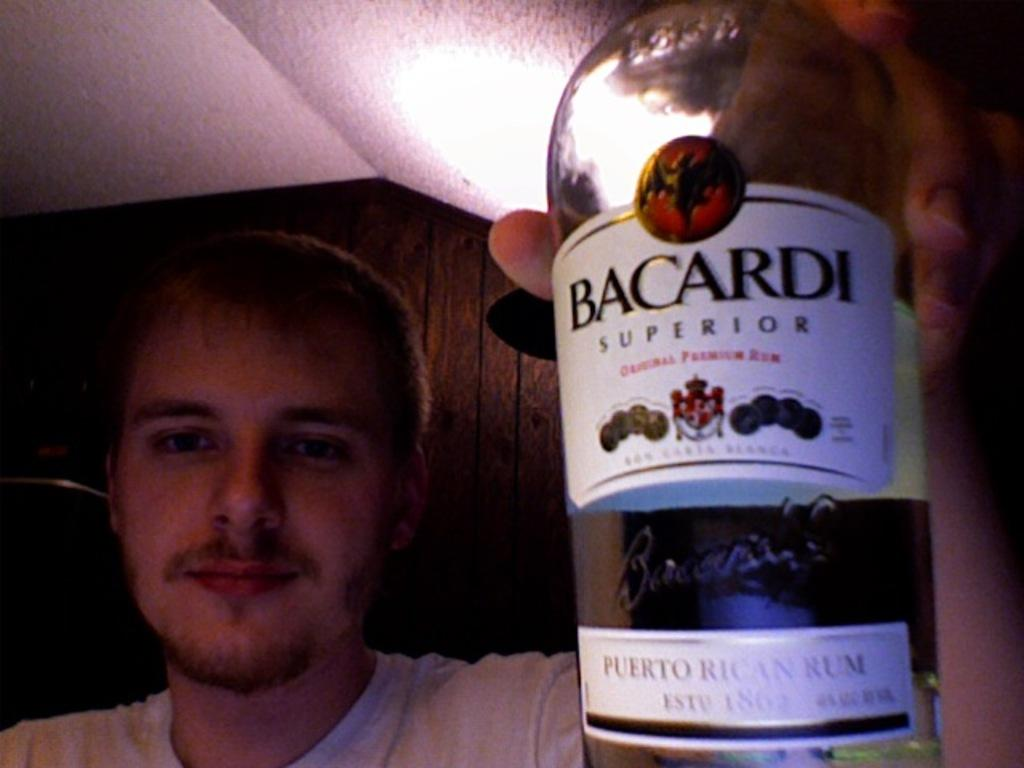<image>
Provide a brief description of the given image. A man wearing a white t-shirt holding up a bottle of Bacardi in his hand. 